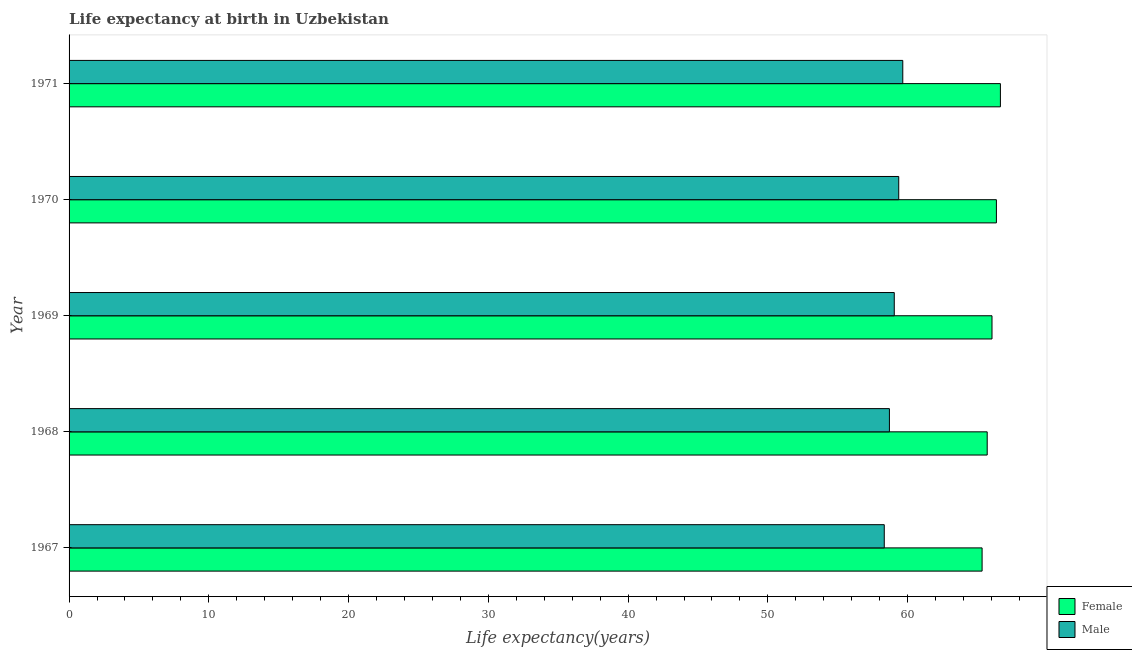How many different coloured bars are there?
Your answer should be very brief. 2. How many groups of bars are there?
Provide a short and direct response. 5. Are the number of bars per tick equal to the number of legend labels?
Give a very brief answer. Yes. How many bars are there on the 1st tick from the top?
Offer a terse response. 2. What is the label of the 4th group of bars from the top?
Offer a terse response. 1968. In how many cases, is the number of bars for a given year not equal to the number of legend labels?
Ensure brevity in your answer.  0. What is the life expectancy(female) in 1968?
Your answer should be compact. 65.69. Across all years, what is the maximum life expectancy(male)?
Give a very brief answer. 59.65. Across all years, what is the minimum life expectancy(male)?
Offer a terse response. 58.33. In which year was the life expectancy(female) maximum?
Offer a very short reply. 1971. In which year was the life expectancy(female) minimum?
Ensure brevity in your answer.  1967. What is the total life expectancy(male) in the graph?
Your answer should be very brief. 295.09. What is the difference between the life expectancy(male) in 1967 and that in 1968?
Make the answer very short. -0.37. What is the difference between the life expectancy(male) in 1968 and the life expectancy(female) in 1970?
Your response must be concise. -7.66. What is the average life expectancy(female) per year?
Give a very brief answer. 66.01. In the year 1971, what is the difference between the life expectancy(female) and life expectancy(male)?
Offer a terse response. 6.99. In how many years, is the life expectancy(female) greater than 18 years?
Your answer should be very brief. 5. What is the ratio of the life expectancy(male) in 1968 to that in 1970?
Your answer should be very brief. 0.99. What is the difference between the highest and the second highest life expectancy(male)?
Offer a terse response. 0.29. What is the difference between the highest and the lowest life expectancy(male)?
Ensure brevity in your answer.  1.33. In how many years, is the life expectancy(male) greater than the average life expectancy(male) taken over all years?
Offer a terse response. 3. Is the sum of the life expectancy(male) in 1967 and 1970 greater than the maximum life expectancy(female) across all years?
Make the answer very short. Yes. What does the 2nd bar from the bottom in 1967 represents?
Your answer should be very brief. Male. How many bars are there?
Provide a succinct answer. 10. How many years are there in the graph?
Offer a terse response. 5. Are the values on the major ticks of X-axis written in scientific E-notation?
Keep it short and to the point. No. Does the graph contain any zero values?
Keep it short and to the point. No. Where does the legend appear in the graph?
Offer a very short reply. Bottom right. How are the legend labels stacked?
Offer a very short reply. Vertical. What is the title of the graph?
Offer a terse response. Life expectancy at birth in Uzbekistan. What is the label or title of the X-axis?
Give a very brief answer. Life expectancy(years). What is the label or title of the Y-axis?
Your response must be concise. Year. What is the Life expectancy(years) in Female in 1967?
Your answer should be very brief. 65.33. What is the Life expectancy(years) of Male in 1967?
Offer a very short reply. 58.33. What is the Life expectancy(years) of Female in 1968?
Offer a very short reply. 65.69. What is the Life expectancy(years) in Male in 1968?
Ensure brevity in your answer.  58.7. What is the Life expectancy(years) in Female in 1969?
Your answer should be compact. 66.04. What is the Life expectancy(years) of Male in 1969?
Ensure brevity in your answer.  59.05. What is the Life expectancy(years) in Female in 1970?
Your answer should be compact. 66.35. What is the Life expectancy(years) of Male in 1970?
Ensure brevity in your answer.  59.37. What is the Life expectancy(years) in Female in 1971?
Ensure brevity in your answer.  66.64. What is the Life expectancy(years) of Male in 1971?
Ensure brevity in your answer.  59.65. Across all years, what is the maximum Life expectancy(years) in Female?
Provide a succinct answer. 66.64. Across all years, what is the maximum Life expectancy(years) in Male?
Offer a very short reply. 59.65. Across all years, what is the minimum Life expectancy(years) of Female?
Your answer should be very brief. 65.33. Across all years, what is the minimum Life expectancy(years) in Male?
Provide a succinct answer. 58.33. What is the total Life expectancy(years) of Female in the graph?
Give a very brief answer. 330.06. What is the total Life expectancy(years) in Male in the graph?
Offer a very short reply. 295.09. What is the difference between the Life expectancy(years) of Female in 1967 and that in 1968?
Ensure brevity in your answer.  -0.36. What is the difference between the Life expectancy(years) of Male in 1967 and that in 1968?
Your answer should be compact. -0.37. What is the difference between the Life expectancy(years) in Female in 1967 and that in 1969?
Your answer should be very brief. -0.71. What is the difference between the Life expectancy(years) in Male in 1967 and that in 1969?
Your answer should be compact. -0.72. What is the difference between the Life expectancy(years) of Female in 1967 and that in 1970?
Offer a very short reply. -1.02. What is the difference between the Life expectancy(years) in Male in 1967 and that in 1970?
Offer a terse response. -1.04. What is the difference between the Life expectancy(years) of Female in 1967 and that in 1971?
Offer a very short reply. -1.31. What is the difference between the Life expectancy(years) of Male in 1967 and that in 1971?
Provide a short and direct response. -1.32. What is the difference between the Life expectancy(years) in Female in 1968 and that in 1969?
Ensure brevity in your answer.  -0.34. What is the difference between the Life expectancy(years) in Male in 1968 and that in 1969?
Provide a succinct answer. -0.35. What is the difference between the Life expectancy(years) of Female in 1968 and that in 1970?
Offer a terse response. -0.66. What is the difference between the Life expectancy(years) in Male in 1968 and that in 1970?
Offer a terse response. -0.67. What is the difference between the Life expectancy(years) in Female in 1968 and that in 1971?
Provide a succinct answer. -0.94. What is the difference between the Life expectancy(years) in Male in 1968 and that in 1971?
Make the answer very short. -0.96. What is the difference between the Life expectancy(years) of Female in 1969 and that in 1970?
Offer a very short reply. -0.32. What is the difference between the Life expectancy(years) in Male in 1969 and that in 1970?
Ensure brevity in your answer.  -0.32. What is the difference between the Life expectancy(years) in Female in 1969 and that in 1971?
Provide a succinct answer. -0.6. What is the difference between the Life expectancy(years) of Male in 1969 and that in 1971?
Offer a terse response. -0.61. What is the difference between the Life expectancy(years) of Female in 1970 and that in 1971?
Your answer should be very brief. -0.29. What is the difference between the Life expectancy(years) in Male in 1970 and that in 1971?
Your answer should be compact. -0.29. What is the difference between the Life expectancy(years) in Female in 1967 and the Life expectancy(years) in Male in 1968?
Ensure brevity in your answer.  6.63. What is the difference between the Life expectancy(years) of Female in 1967 and the Life expectancy(years) of Male in 1969?
Offer a terse response. 6.29. What is the difference between the Life expectancy(years) of Female in 1967 and the Life expectancy(years) of Male in 1970?
Offer a terse response. 5.96. What is the difference between the Life expectancy(years) in Female in 1967 and the Life expectancy(years) in Male in 1971?
Your response must be concise. 5.68. What is the difference between the Life expectancy(years) in Female in 1968 and the Life expectancy(years) in Male in 1969?
Your answer should be very brief. 6.65. What is the difference between the Life expectancy(years) in Female in 1968 and the Life expectancy(years) in Male in 1970?
Provide a short and direct response. 6.33. What is the difference between the Life expectancy(years) of Female in 1968 and the Life expectancy(years) of Male in 1971?
Ensure brevity in your answer.  6.04. What is the difference between the Life expectancy(years) in Female in 1969 and the Life expectancy(years) in Male in 1970?
Ensure brevity in your answer.  6.67. What is the difference between the Life expectancy(years) in Female in 1969 and the Life expectancy(years) in Male in 1971?
Make the answer very short. 6.38. What is the average Life expectancy(years) in Female per year?
Ensure brevity in your answer.  66.01. What is the average Life expectancy(years) in Male per year?
Ensure brevity in your answer.  59.02. In the year 1967, what is the difference between the Life expectancy(years) in Female and Life expectancy(years) in Male?
Keep it short and to the point. 7. In the year 1968, what is the difference between the Life expectancy(years) in Female and Life expectancy(years) in Male?
Make the answer very short. 7. In the year 1969, what is the difference between the Life expectancy(years) of Female and Life expectancy(years) of Male?
Your answer should be compact. 6.99. In the year 1970, what is the difference between the Life expectancy(years) in Female and Life expectancy(years) in Male?
Your answer should be very brief. 6.99. In the year 1971, what is the difference between the Life expectancy(years) of Female and Life expectancy(years) of Male?
Offer a very short reply. 6.99. What is the ratio of the Life expectancy(years) of Female in 1967 to that in 1968?
Provide a succinct answer. 0.99. What is the ratio of the Life expectancy(years) in Female in 1967 to that in 1969?
Your answer should be compact. 0.99. What is the ratio of the Life expectancy(years) in Male in 1967 to that in 1969?
Make the answer very short. 0.99. What is the ratio of the Life expectancy(years) in Female in 1967 to that in 1970?
Offer a terse response. 0.98. What is the ratio of the Life expectancy(years) in Male in 1967 to that in 1970?
Keep it short and to the point. 0.98. What is the ratio of the Life expectancy(years) of Female in 1967 to that in 1971?
Ensure brevity in your answer.  0.98. What is the ratio of the Life expectancy(years) in Male in 1967 to that in 1971?
Your answer should be very brief. 0.98. What is the ratio of the Life expectancy(years) in Female in 1968 to that in 1970?
Ensure brevity in your answer.  0.99. What is the ratio of the Life expectancy(years) of Female in 1968 to that in 1971?
Your answer should be compact. 0.99. What is the ratio of the Life expectancy(years) in Male in 1968 to that in 1971?
Your response must be concise. 0.98. What is the ratio of the Life expectancy(years) of Female in 1969 to that in 1970?
Your answer should be compact. 1. What is the ratio of the Life expectancy(years) of Male in 1969 to that in 1970?
Offer a terse response. 0.99. What is the ratio of the Life expectancy(years) in Male in 1969 to that in 1971?
Keep it short and to the point. 0.99. What is the ratio of the Life expectancy(years) of Female in 1970 to that in 1971?
Your answer should be compact. 1. What is the difference between the highest and the second highest Life expectancy(years) of Female?
Your answer should be very brief. 0.29. What is the difference between the highest and the second highest Life expectancy(years) in Male?
Your answer should be compact. 0.29. What is the difference between the highest and the lowest Life expectancy(years) in Female?
Keep it short and to the point. 1.31. What is the difference between the highest and the lowest Life expectancy(years) in Male?
Offer a terse response. 1.32. 